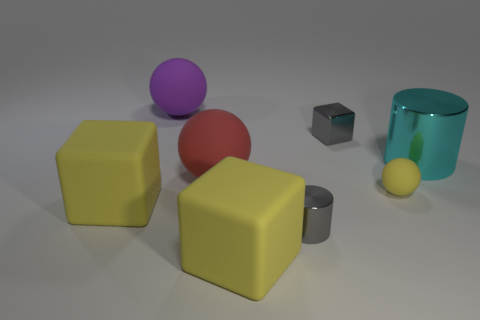There is a yellow thing that is the same shape as the red rubber object; what is its size?
Ensure brevity in your answer.  Small. There is a thing that is the same color as the tiny cylinder; what is it made of?
Offer a terse response. Metal. What size is the block to the left of the big red matte object?
Ensure brevity in your answer.  Large. Are there any red spheres that are left of the large yellow rubber block that is to the left of the big purple matte thing?
Provide a short and direct response. No. How many other things are the same shape as the cyan metal object?
Offer a very short reply. 1. Do the purple rubber thing and the big cyan object have the same shape?
Provide a succinct answer. No. The sphere that is both in front of the big cyan cylinder and to the left of the small gray shiny block is what color?
Offer a terse response. Red. What is the size of the object that is the same color as the tiny block?
Give a very brief answer. Small. What number of small things are either green metal cylinders or purple matte things?
Offer a terse response. 0. Are there any other things that have the same color as the tiny matte object?
Provide a short and direct response. Yes. 